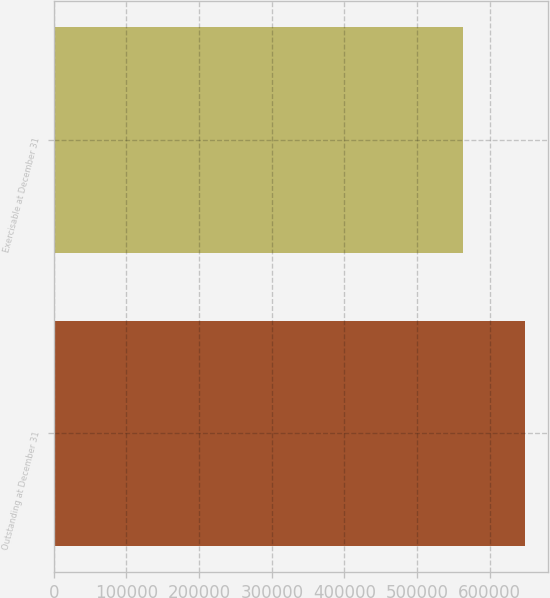<chart> <loc_0><loc_0><loc_500><loc_500><bar_chart><fcel>Outstanding at December 31<fcel>Exercisable at December 31<nl><fcel>648034<fcel>562684<nl></chart> 